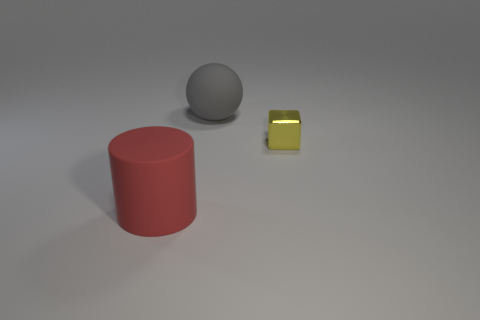Add 1 metal objects. How many objects exist? 4 Subtract all balls. How many objects are left? 2 Subtract 0 green cylinders. How many objects are left? 3 Subtract all small purple balls. Subtract all small yellow metal things. How many objects are left? 2 Add 3 large objects. How many large objects are left? 5 Add 2 big blue rubber blocks. How many big blue rubber blocks exist? 2 